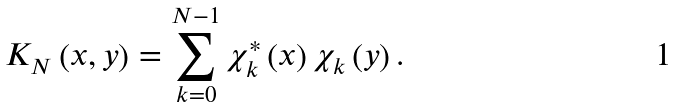<formula> <loc_0><loc_0><loc_500><loc_500>K _ { N } \left ( x , y \right ) = \sum _ { k = 0 } ^ { N - 1 } \chi _ { k } ^ { \ast } \left ( x \right ) \chi _ { k } \left ( y \right ) .</formula> 